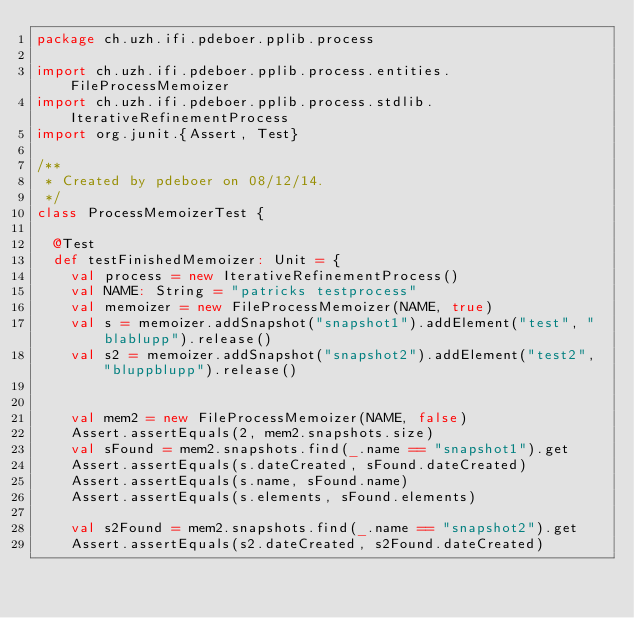Convert code to text. <code><loc_0><loc_0><loc_500><loc_500><_Scala_>package ch.uzh.ifi.pdeboer.pplib.process

import ch.uzh.ifi.pdeboer.pplib.process.entities.FileProcessMemoizer
import ch.uzh.ifi.pdeboer.pplib.process.stdlib.IterativeRefinementProcess
import org.junit.{Assert, Test}

/**
 * Created by pdeboer on 08/12/14.
 */
class ProcessMemoizerTest {

	@Test
	def testFinishedMemoizer: Unit = {
		val process = new IterativeRefinementProcess()
		val NAME: String = "patricks testprocess"
		val memoizer = new FileProcessMemoizer(NAME, true)
		val s = memoizer.addSnapshot("snapshot1").addElement("test", "blablupp").release()
		val s2 = memoizer.addSnapshot("snapshot2").addElement("test2", "bluppblupp").release()


		val mem2 = new FileProcessMemoizer(NAME, false)
		Assert.assertEquals(2, mem2.snapshots.size)
		val sFound = mem2.snapshots.find(_.name == "snapshot1").get
		Assert.assertEquals(s.dateCreated, sFound.dateCreated)
		Assert.assertEquals(s.name, sFound.name)
		Assert.assertEquals(s.elements, sFound.elements)

		val s2Found = mem2.snapshots.find(_.name == "snapshot2").get
		Assert.assertEquals(s2.dateCreated, s2Found.dateCreated)</code> 